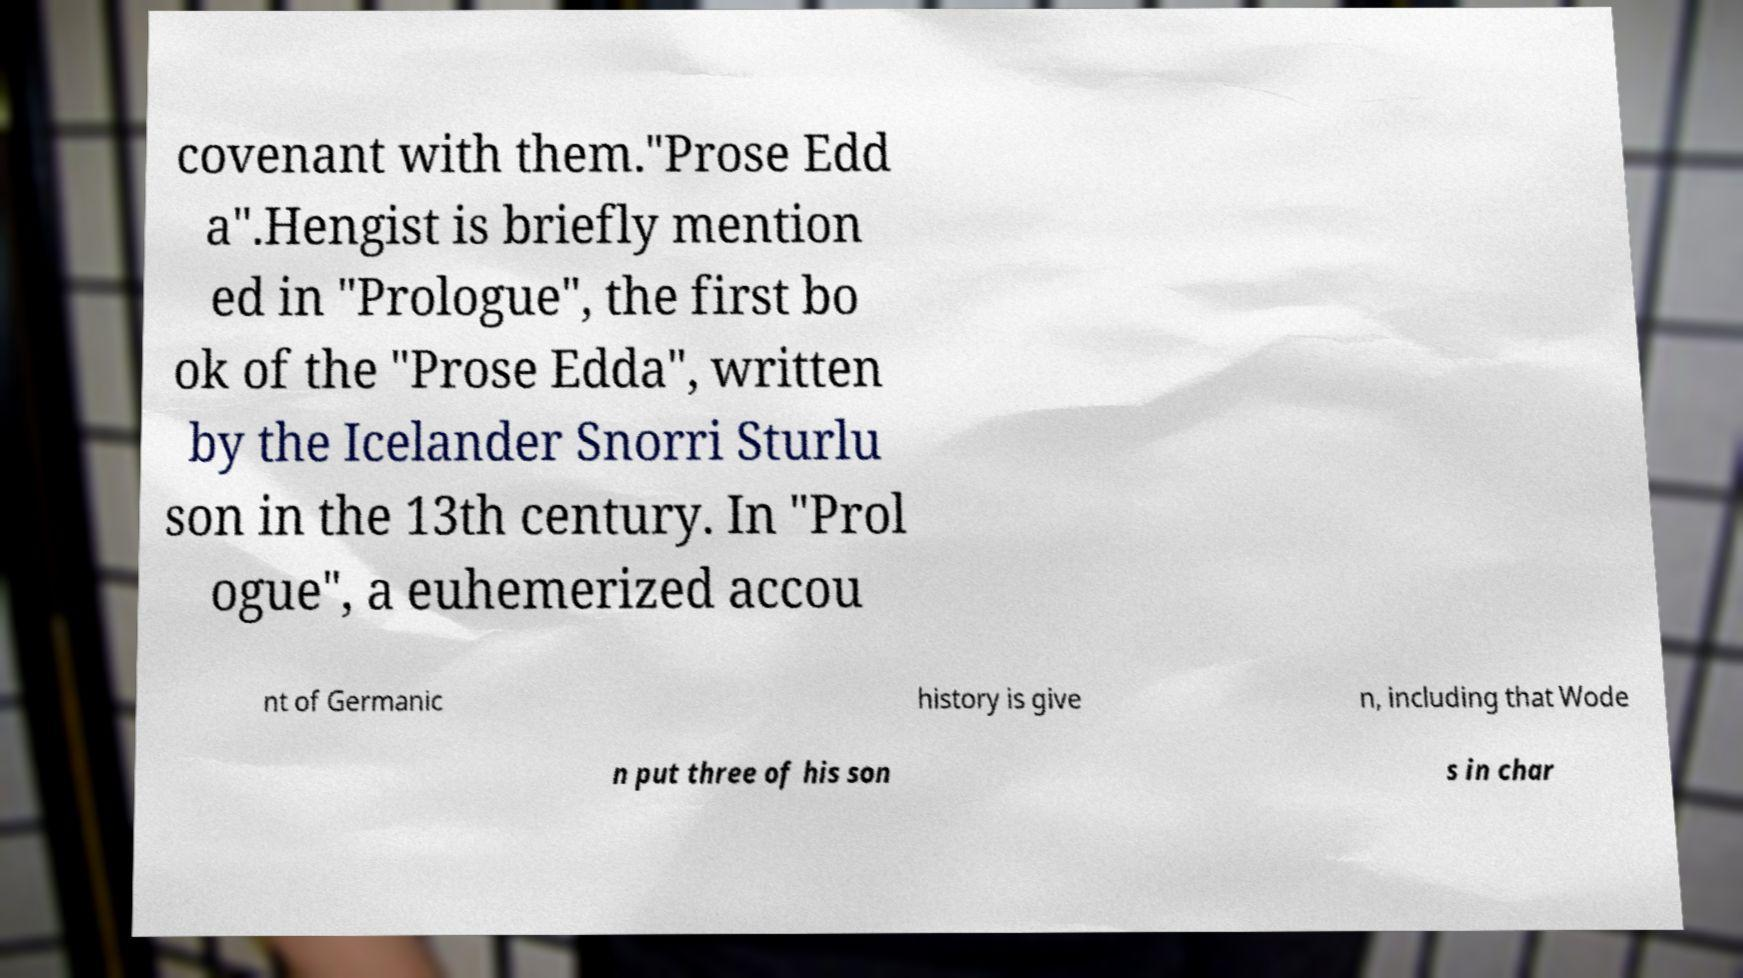Can you read and provide the text displayed in the image?This photo seems to have some interesting text. Can you extract and type it out for me? covenant with them."Prose Edd a".Hengist is briefly mention ed in "Prologue", the first bo ok of the "Prose Edda", written by the Icelander Snorri Sturlu son in the 13th century. In "Prol ogue", a euhemerized accou nt of Germanic history is give n, including that Wode n put three of his son s in char 